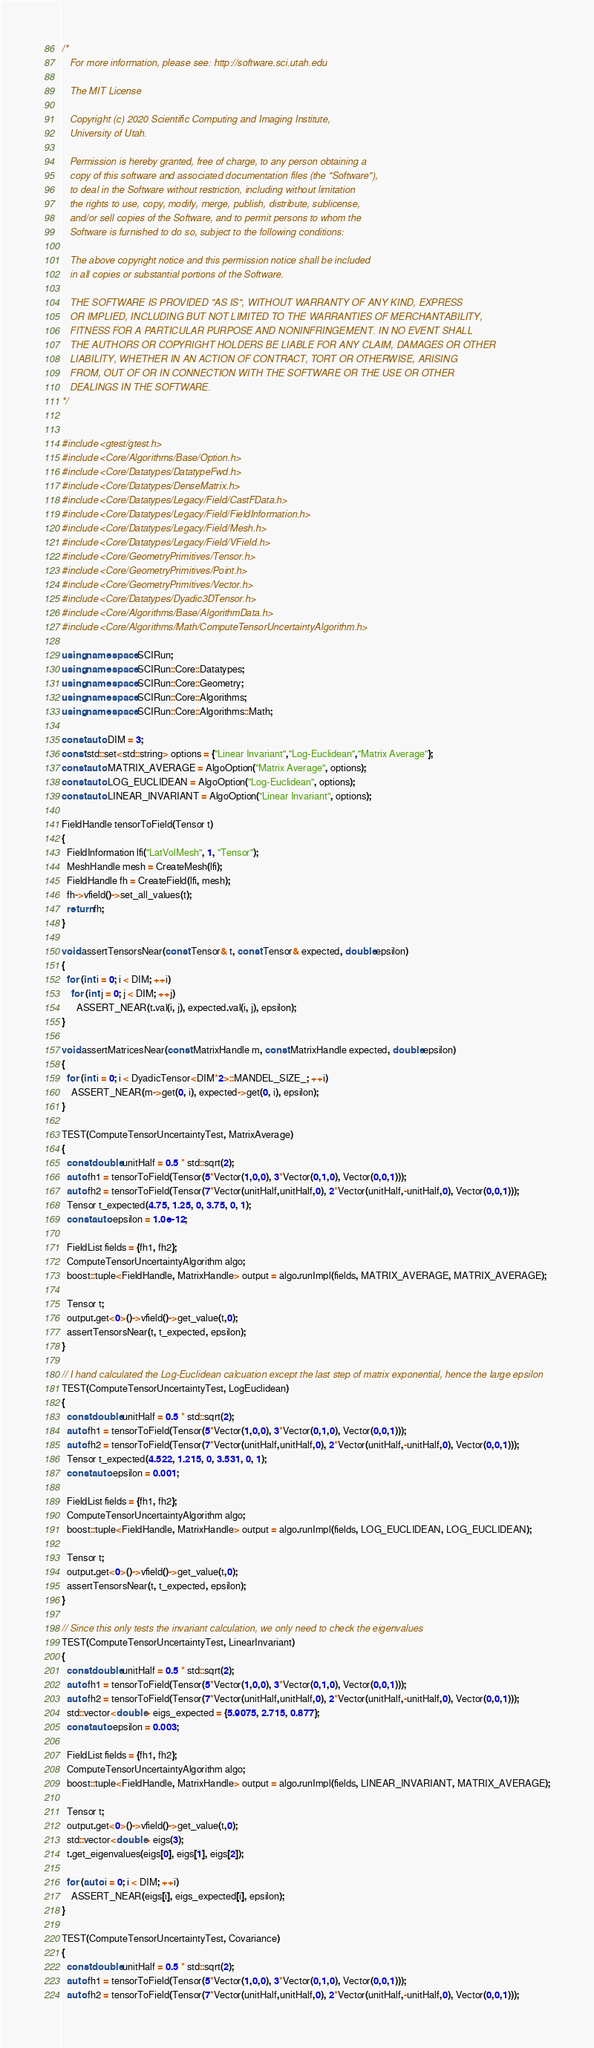<code> <loc_0><loc_0><loc_500><loc_500><_C++_>/*
   For more information, please see: http://software.sci.utah.edu

   The MIT License

   Copyright (c) 2020 Scientific Computing and Imaging Institute,
   University of Utah.

   Permission is hereby granted, free of charge, to any person obtaining a
   copy of this software and associated documentation files (the "Software"),
   to deal in the Software without restriction, including without limitation
   the rights to use, copy, modify, merge, publish, distribute, sublicense,
   and/or sell copies of the Software, and to permit persons to whom the
   Software is furnished to do so, subject to the following conditions:

   The above copyright notice and this permission notice shall be included
   in all copies or substantial portions of the Software.

   THE SOFTWARE IS PROVIDED "AS IS", WITHOUT WARRANTY OF ANY KIND, EXPRESS
   OR IMPLIED, INCLUDING BUT NOT LIMITED TO THE WARRANTIES OF MERCHANTABILITY,
   FITNESS FOR A PARTICULAR PURPOSE AND NONINFRINGEMENT. IN NO EVENT SHALL
   THE AUTHORS OR COPYRIGHT HOLDERS BE LIABLE FOR ANY CLAIM, DAMAGES OR OTHER
   LIABILITY, WHETHER IN AN ACTION OF CONTRACT, TORT OR OTHERWISE, ARISING
   FROM, OUT OF OR IN CONNECTION WITH THE SOFTWARE OR THE USE OR OTHER
   DEALINGS IN THE SOFTWARE.
*/


#include <gtest/gtest.h>
#include <Core/Algorithms/Base/Option.h>
#include <Core/Datatypes/DatatypeFwd.h>
#include <Core/Datatypes/DenseMatrix.h>
#include <Core/Datatypes/Legacy/Field/CastFData.h>
#include <Core/Datatypes/Legacy/Field/FieldInformation.h>
#include <Core/Datatypes/Legacy/Field/Mesh.h>
#include <Core/Datatypes/Legacy/Field/VField.h>
#include <Core/GeometryPrimitives/Tensor.h>
#include <Core/GeometryPrimitives/Point.h>
#include <Core/GeometryPrimitives/Vector.h>
#include <Core/Datatypes/Dyadic3DTensor.h>
#include <Core/Algorithms/Base/AlgorithmData.h>
#include <Core/Algorithms/Math/ComputeTensorUncertaintyAlgorithm.h>

using namespace SCIRun;
using namespace SCIRun::Core::Datatypes;
using namespace SCIRun::Core::Geometry;
using namespace SCIRun::Core::Algorithms;
using namespace SCIRun::Core::Algorithms::Math;

const auto DIM = 3;
const std::set<std::string> options = {"Linear Invariant","Log-Euclidean","Matrix Average"};
const auto MATRIX_AVERAGE = AlgoOption("Matrix Average", options);
const auto LOG_EUCLIDEAN = AlgoOption("Log-Euclidean", options);
const auto LINEAR_INVARIANT = AlgoOption("Linear Invariant", options);

FieldHandle tensorToField(Tensor t)
{
  FieldInformation lfi("LatVolMesh", 1, "Tensor");
  MeshHandle mesh = CreateMesh(lfi);
  FieldHandle fh = CreateField(lfi, mesh);
  fh->vfield()->set_all_values(t);
  return fh;
}

void assertTensorsNear(const Tensor& t, const Tensor& expected, double epsilon)
{
  for (int i = 0; i < DIM; ++i)
    for (int j = 0; j < DIM; ++j)
      ASSERT_NEAR(t.val(i, j), expected.val(i, j), epsilon);
}

void assertMatricesNear(const MatrixHandle m, const MatrixHandle expected, double epsilon)
{
  for (int i = 0; i < DyadicTensor<DIM*2>::MANDEL_SIZE_; ++i)
    ASSERT_NEAR(m->get(0, i), expected->get(0, i), epsilon);
}

TEST(ComputeTensorUncertaintyTest, MatrixAverage)
{
  const double unitHalf = 0.5 * std::sqrt(2);
  auto fh1 = tensorToField(Tensor(5*Vector(1,0,0), 3*Vector(0,1,0), Vector(0,0,1)));
  auto fh2 = tensorToField(Tensor(7*Vector(unitHalf,unitHalf,0), 2*Vector(unitHalf,-unitHalf,0), Vector(0,0,1)));
  Tensor t_expected(4.75, 1.25, 0, 3.75, 0, 1);
  const auto epsilon = 1.0e-12;

  FieldList fields = {fh1, fh2};
  ComputeTensorUncertaintyAlgorithm algo;
  boost::tuple<FieldHandle, MatrixHandle> output = algo.runImpl(fields, MATRIX_AVERAGE, MATRIX_AVERAGE);

  Tensor t;
  output.get<0>()->vfield()->get_value(t,0);
  assertTensorsNear(t, t_expected, epsilon);
}

// I hand calculated the Log-Euclidean calcuation except the last step of matrix exponential, hence the large epsilon
TEST(ComputeTensorUncertaintyTest, LogEuclidean)
{
  const double unitHalf = 0.5 * std::sqrt(2);
  auto fh1 = tensorToField(Tensor(5*Vector(1,0,0), 3*Vector(0,1,0), Vector(0,0,1)));
  auto fh2 = tensorToField(Tensor(7*Vector(unitHalf,unitHalf,0), 2*Vector(unitHalf,-unitHalf,0), Vector(0,0,1)));
  Tensor t_expected(4.522, 1.215, 0, 3.531, 0, 1);
  const auto epsilon = 0.001;

  FieldList fields = {fh1, fh2};
  ComputeTensorUncertaintyAlgorithm algo;
  boost::tuple<FieldHandle, MatrixHandle> output = algo.runImpl(fields, LOG_EUCLIDEAN, LOG_EUCLIDEAN);

  Tensor t;
  output.get<0>()->vfield()->get_value(t,0);
  assertTensorsNear(t, t_expected, epsilon);
}

// Since this only tests the invariant calculation, we only need to check the eigenvalues
TEST(ComputeTensorUncertaintyTest, LinearInvariant)
{
  const double unitHalf = 0.5 * std::sqrt(2);
  auto fh1 = tensorToField(Tensor(5*Vector(1,0,0), 3*Vector(0,1,0), Vector(0,0,1)));
  auto fh2 = tensorToField(Tensor(7*Vector(unitHalf,unitHalf,0), 2*Vector(unitHalf,-unitHalf,0), Vector(0,0,1)));
  std::vector<double> eigs_expected = {5.9075, 2.715, 0.877};
  const auto epsilon = 0.003;

  FieldList fields = {fh1, fh2};
  ComputeTensorUncertaintyAlgorithm algo;
  boost::tuple<FieldHandle, MatrixHandle> output = algo.runImpl(fields, LINEAR_INVARIANT, MATRIX_AVERAGE);

  Tensor t;
  output.get<0>()->vfield()->get_value(t,0);
  std::vector<double> eigs(3);
  t.get_eigenvalues(eigs[0], eigs[1], eigs[2]);

  for (auto i = 0; i < DIM; ++i)
    ASSERT_NEAR(eigs[i], eigs_expected[i], epsilon);
}

TEST(ComputeTensorUncertaintyTest, Covariance)
{
  const double unitHalf = 0.5 * std::sqrt(2);
  auto fh1 = tensorToField(Tensor(5*Vector(1,0,0), 3*Vector(0,1,0), Vector(0,0,1)));
  auto fh2 = tensorToField(Tensor(7*Vector(unitHalf,unitHalf,0), 2*Vector(unitHalf,-unitHalf,0), Vector(0,0,1)));</code> 